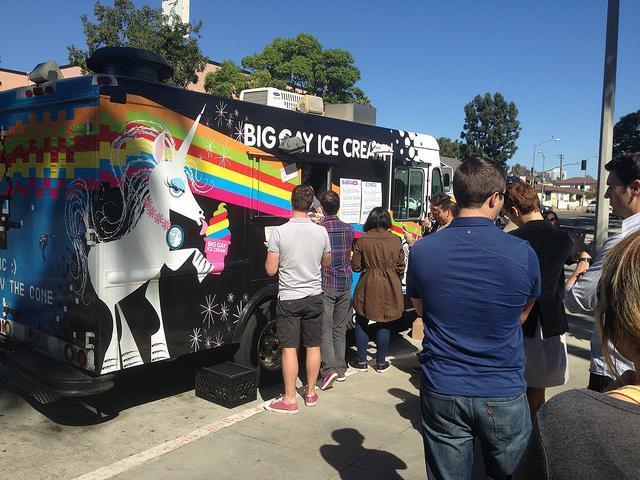How many people are there?
Give a very brief answer. 7. How many tusks does the elephant have?
Give a very brief answer. 0. 